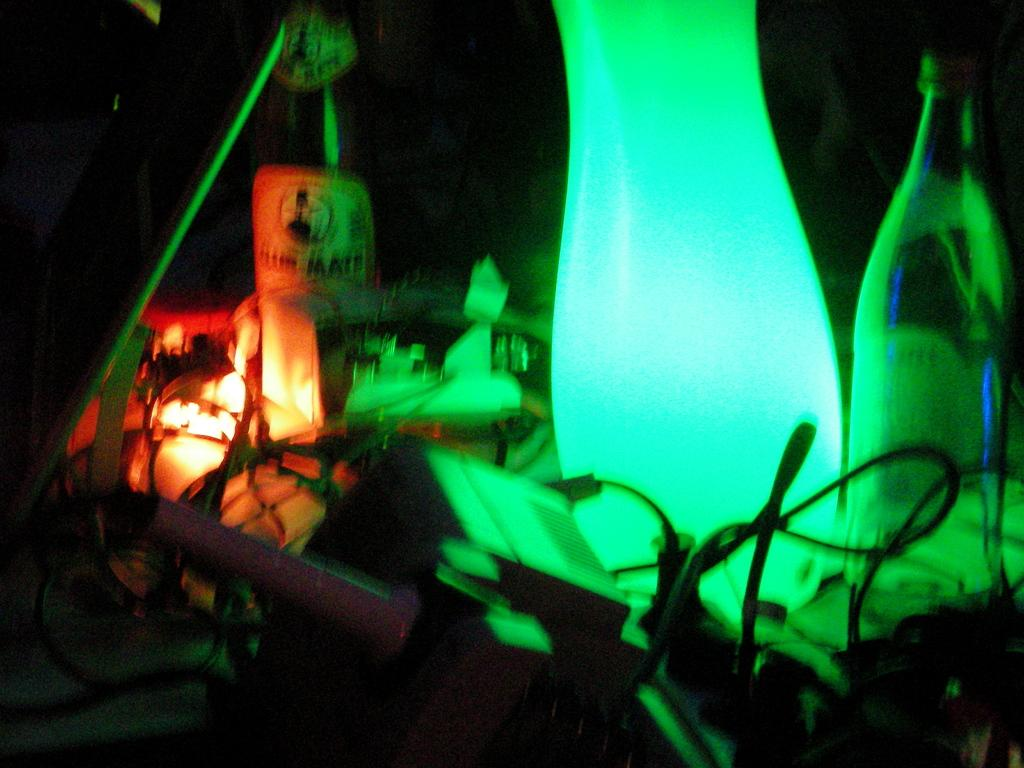What can be seen in the image that people might use to stay hydrated? There is a water bottle in the image. What can be seen in the image that provides illumination? There is a light in the image. What type of religion is being practiced in the image? There is no indication of any religious practice in the image; it only features a water bottle and a light. Can you see a dog in the image? No, there is no dog present in the image. 